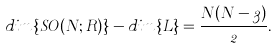Convert formula to latex. <formula><loc_0><loc_0><loc_500><loc_500>d i m \left \{ S O ( N ; R ) \right \} - d i m \left \{ L \right \} = \frac { N ( N - 3 ) } { 2 } .</formula> 